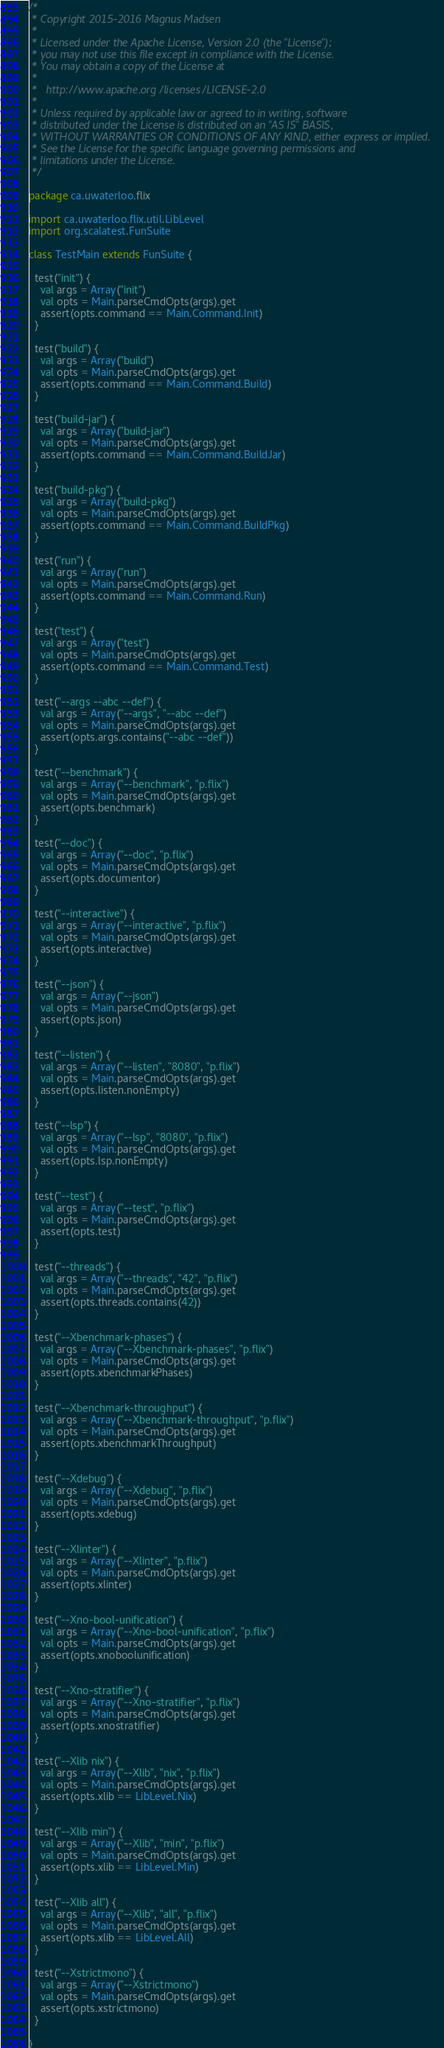Convert code to text. <code><loc_0><loc_0><loc_500><loc_500><_Scala_>/*
 * Copyright 2015-2016 Magnus Madsen
 *
 * Licensed under the Apache License, Version 2.0 (the "License");
 * you may not use this file except in compliance with the License.
 * You may obtain a copy of the License at
 *
 *   http://www.apache.org/licenses/LICENSE-2.0
 *
 * Unless required by applicable law or agreed to in writing, software
 * distributed under the License is distributed on an "AS IS" BASIS,
 * WITHOUT WARRANTIES OR CONDITIONS OF ANY KIND, either express or implied.
 * See the License for the specific language governing permissions and
 * limitations under the License.
 */

package ca.uwaterloo.flix

import ca.uwaterloo.flix.util.LibLevel
import org.scalatest.FunSuite

class TestMain extends FunSuite {

  test("init") {
    val args = Array("init")
    val opts = Main.parseCmdOpts(args).get
    assert(opts.command == Main.Command.Init)
  }

  test("build") {
    val args = Array("build")
    val opts = Main.parseCmdOpts(args).get
    assert(opts.command == Main.Command.Build)
  }

  test("build-jar") {
    val args = Array("build-jar")
    val opts = Main.parseCmdOpts(args).get
    assert(opts.command == Main.Command.BuildJar)
  }

  test("build-pkg") {
    val args = Array("build-pkg")
    val opts = Main.parseCmdOpts(args).get
    assert(opts.command == Main.Command.BuildPkg)
  }

  test("run") {
    val args = Array("run")
    val opts = Main.parseCmdOpts(args).get
    assert(opts.command == Main.Command.Run)
  }

  test("test") {
    val args = Array("test")
    val opts = Main.parseCmdOpts(args).get
    assert(opts.command == Main.Command.Test)
  }

  test("--args --abc --def") {
    val args = Array("--args", "--abc --def")
    val opts = Main.parseCmdOpts(args).get
    assert(opts.args.contains("--abc --def"))
  }

  test("--benchmark") {
    val args = Array("--benchmark", "p.flix")
    val opts = Main.parseCmdOpts(args).get
    assert(opts.benchmark)
  }

  test("--doc") {
    val args = Array("--doc", "p.flix")
    val opts = Main.parseCmdOpts(args).get
    assert(opts.documentor)
  }

  test("--interactive") {
    val args = Array("--interactive", "p.flix")
    val opts = Main.parseCmdOpts(args).get
    assert(opts.interactive)
  }

  test("--json") {
    val args = Array("--json")
    val opts = Main.parseCmdOpts(args).get
    assert(opts.json)
  }

  test("--listen") {
    val args = Array("--listen", "8080", "p.flix")
    val opts = Main.parseCmdOpts(args).get
    assert(opts.listen.nonEmpty)
  }

  test("--lsp") {
    val args = Array("--lsp", "8080", "p.flix")
    val opts = Main.parseCmdOpts(args).get
    assert(opts.lsp.nonEmpty)
  }

  test("--test") {
    val args = Array("--test", "p.flix")
    val opts = Main.parseCmdOpts(args).get
    assert(opts.test)
  }

  test("--threads") {
    val args = Array("--threads", "42", "p.flix")
    val opts = Main.parseCmdOpts(args).get
    assert(opts.threads.contains(42))
  }

  test("--Xbenchmark-phases") {
    val args = Array("--Xbenchmark-phases", "p.flix")
    val opts = Main.parseCmdOpts(args).get
    assert(opts.xbenchmarkPhases)
  }

  test("--Xbenchmark-throughput") {
    val args = Array("--Xbenchmark-throughput", "p.flix")
    val opts = Main.parseCmdOpts(args).get
    assert(opts.xbenchmarkThroughput)
  }

  test("--Xdebug") {
    val args = Array("--Xdebug", "p.flix")
    val opts = Main.parseCmdOpts(args).get
    assert(opts.xdebug)
  }

  test("--Xlinter") {
    val args = Array("--Xlinter", "p.flix")
    val opts = Main.parseCmdOpts(args).get
    assert(opts.xlinter)
  }

  test("--Xno-bool-unification") {
    val args = Array("--Xno-bool-unification", "p.flix")
    val opts = Main.parseCmdOpts(args).get
    assert(opts.xnoboolunification)
  }

  test("--Xno-stratifier") {
    val args = Array("--Xno-stratifier", "p.flix")
    val opts = Main.parseCmdOpts(args).get
    assert(opts.xnostratifier)
  }

  test("--Xlib nix") {
    val args = Array("--Xlib", "nix", "p.flix")
    val opts = Main.parseCmdOpts(args).get
    assert(opts.xlib == LibLevel.Nix)
  }

  test("--Xlib min") {
    val args = Array("--Xlib", "min", "p.flix")
    val opts = Main.parseCmdOpts(args).get
    assert(opts.xlib == LibLevel.Min)
  }

  test("--Xlib all") {
    val args = Array("--Xlib", "all", "p.flix")
    val opts = Main.parseCmdOpts(args).get
    assert(opts.xlib == LibLevel.All)
  }

  test("--Xstrictmono") {
    val args = Array("--Xstrictmono")
    val opts = Main.parseCmdOpts(args).get
    assert(opts.xstrictmono)
  }

}
</code> 